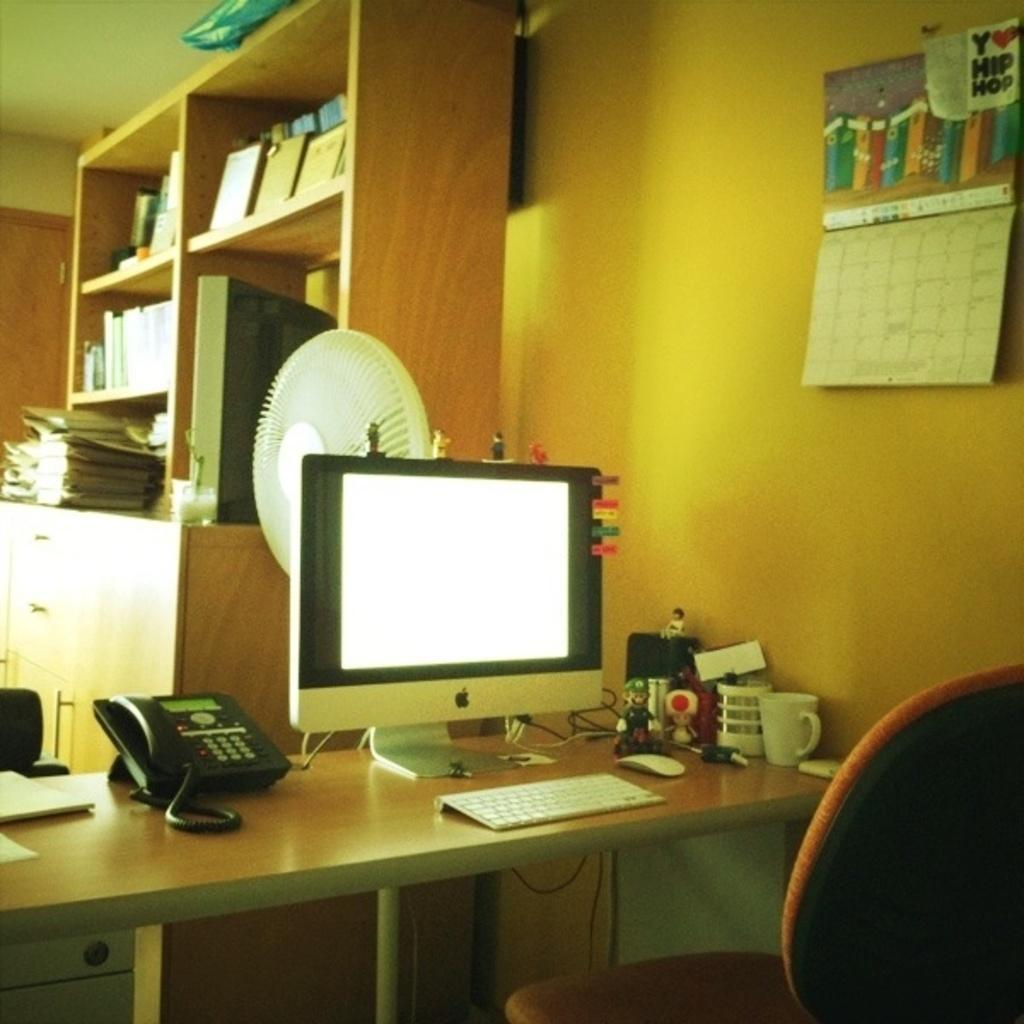What type of furniture is in the image? There is a table and a chair in the image. What electronic devices are on the table? A monitor and a phone are on the table. Are there any objects on the table besides the electronic devices? Yes, there are other objects on the table. What can be seen on the wall in the foreground? There is a poster on a wall in the foreground. What is visible in the background of the image? There is a wall in the background of the image. Is there any storage for books in the image? Yes, there is a wooden rack with books in the image. What type of voyage is depicted in the image? There is no voyage depicted in the image; it features a table, chair, electronic devices, and other objects. What color is the light emitted from the phone in the image? There is no light emitted from the phone in the image; it is a still image and does not show any light sources. 